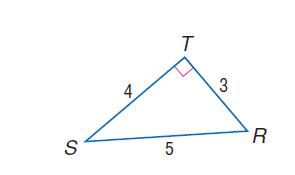Answer the mathemtical geometry problem and directly provide the correct option letter.
Question: find \cos R.
Choices: A: 0.2 B: 0.4 C: 0.6 D: 0.8 C 